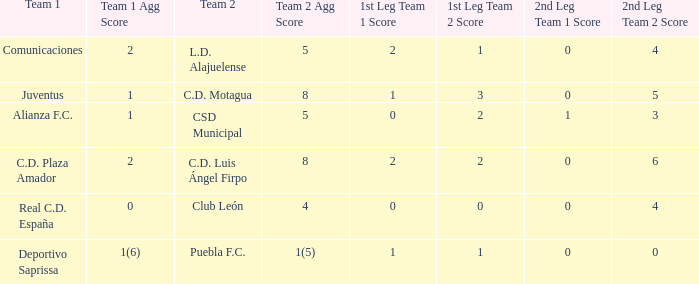What is the 1st leg where Team 1 is C.D. Plaza Amador? 2 - 2. Write the full table. {'header': ['Team 1', 'Team 1 Agg Score', 'Team 2', 'Team 2 Agg Score', '1st Leg Team 1 Score', '1st Leg Team 2 Score', '2nd Leg Team 1 Score', '2nd Leg Team 2 Score'], 'rows': [['Comunicaciones', '2', 'L.D. Alajuelense', '5', '2', '1', '0', '4'], ['Juventus', '1', 'C.D. Motagua', '8', '1', '3', '0', '5'], ['Alianza F.C.', '1', 'CSD Municipal', '5', '0', '2', '1', '3'], ['C.D. Plaza Amador', '2', 'C.D. Luis Ángel Firpo', '8', '2', '2', '0', '6'], ['Real C.D. España', '0', 'Club León', '4', '0', '0', '0', '4'], ['Deportivo Saprissa', '1(6)', 'Puebla F.C.', '1(5)', '1', '1', '0', '0']]} 